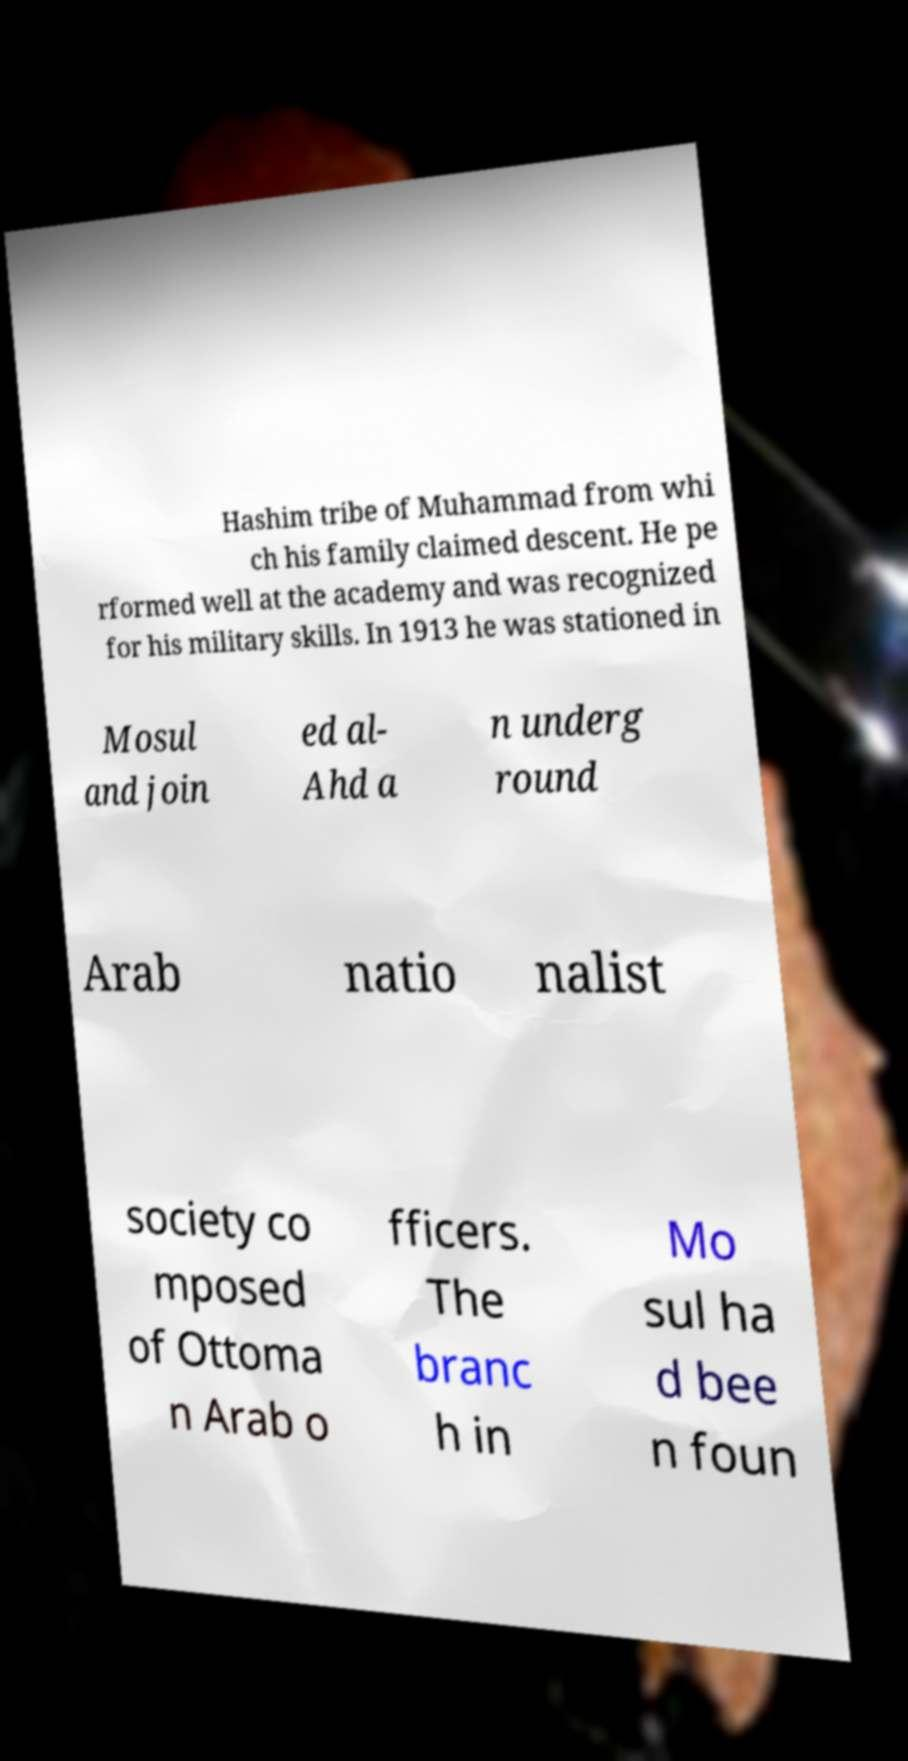For documentation purposes, I need the text within this image transcribed. Could you provide that? Hashim tribe of Muhammad from whi ch his family claimed descent. He pe rformed well at the academy and was recognized for his military skills. In 1913 he was stationed in Mosul and join ed al- Ahd a n underg round Arab natio nalist society co mposed of Ottoma n Arab o fficers. The branc h in Mo sul ha d bee n foun 